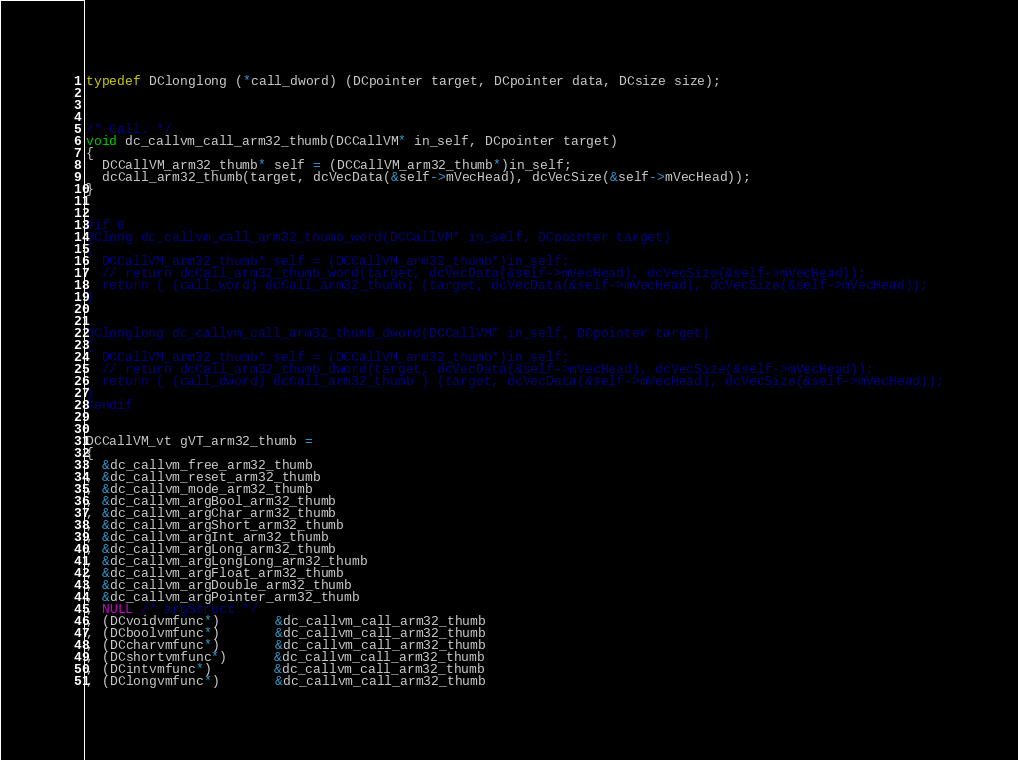<code> <loc_0><loc_0><loc_500><loc_500><_C_>typedef DClonglong (*call_dword) (DCpointer target, DCpointer data, DCsize size);



/* Call. */
void dc_callvm_call_arm32_thumb(DCCallVM* in_self, DCpointer target)
{
  DCCallVM_arm32_thumb* self = (DCCallVM_arm32_thumb*)in_self;
  dcCall_arm32_thumb(target, dcVecData(&self->mVecHead), dcVecSize(&self->mVecHead));
}


#if 0
DClong dc_callvm_call_arm32_thumb_word(DCCallVM* in_self, DCpointer target)
{
  DCCallVM_arm32_thumb* self = (DCCallVM_arm32_thumb*)in_self;
  // return dcCall_arm32_thumb_word(target, dcVecData(&self->mVecHead), dcVecSize(&self->mVecHead));
  return ( (call_word) dcCall_arm32_thumb) (target, dcVecData(&self->mVecHead), dcVecSize(&self->mVecHead));
}


DClonglong dc_callvm_call_arm32_thumb_dword(DCCallVM* in_self, DCpointer target)
{
  DCCallVM_arm32_thumb* self = (DCCallVM_arm32_thumb*)in_self;
  // return dcCall_arm32_thumb_dword(target, dcVecData(&self->mVecHead), dcVecSize(&self->mVecHead));
  return ( (call_dword) dcCall_arm32_thumb ) (target, dcVecData(&self->mVecHead), dcVecSize(&self->mVecHead));
}
#endif


DCCallVM_vt gVT_arm32_thumb =
{
  &dc_callvm_free_arm32_thumb
, &dc_callvm_reset_arm32_thumb
, &dc_callvm_mode_arm32_thumb
, &dc_callvm_argBool_arm32_thumb
, &dc_callvm_argChar_arm32_thumb
, &dc_callvm_argShort_arm32_thumb 
, &dc_callvm_argInt_arm32_thumb
, &dc_callvm_argLong_arm32_thumb
, &dc_callvm_argLongLong_arm32_thumb
, &dc_callvm_argFloat_arm32_thumb
, &dc_callvm_argDouble_arm32_thumb
, &dc_callvm_argPointer_arm32_thumb
, NULL /* argStruct */
, (DCvoidvmfunc*)       &dc_callvm_call_arm32_thumb
, (DCboolvmfunc*)       &dc_callvm_call_arm32_thumb
, (DCcharvmfunc*)       &dc_callvm_call_arm32_thumb
, (DCshortvmfunc*)      &dc_callvm_call_arm32_thumb
, (DCintvmfunc*)        &dc_callvm_call_arm32_thumb
, (DClongvmfunc*)       &dc_callvm_call_arm32_thumb</code> 